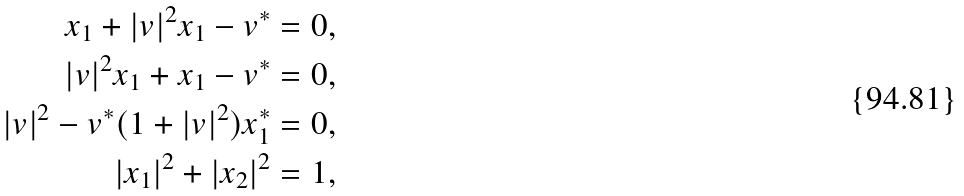<formula> <loc_0><loc_0><loc_500><loc_500>x _ { 1 } + | v | ^ { 2 } x _ { 1 } - v ^ { * } = 0 , \\ | v | ^ { 2 } x _ { 1 } + x _ { 1 } - v ^ { * } = 0 , \\ | v | ^ { 2 } - v ^ { * } ( 1 + | v | ^ { 2 } ) x _ { 1 } ^ { * } = 0 , \\ | x _ { 1 } | ^ { 2 } + | x _ { 2 } | ^ { 2 } = 1 ,</formula> 